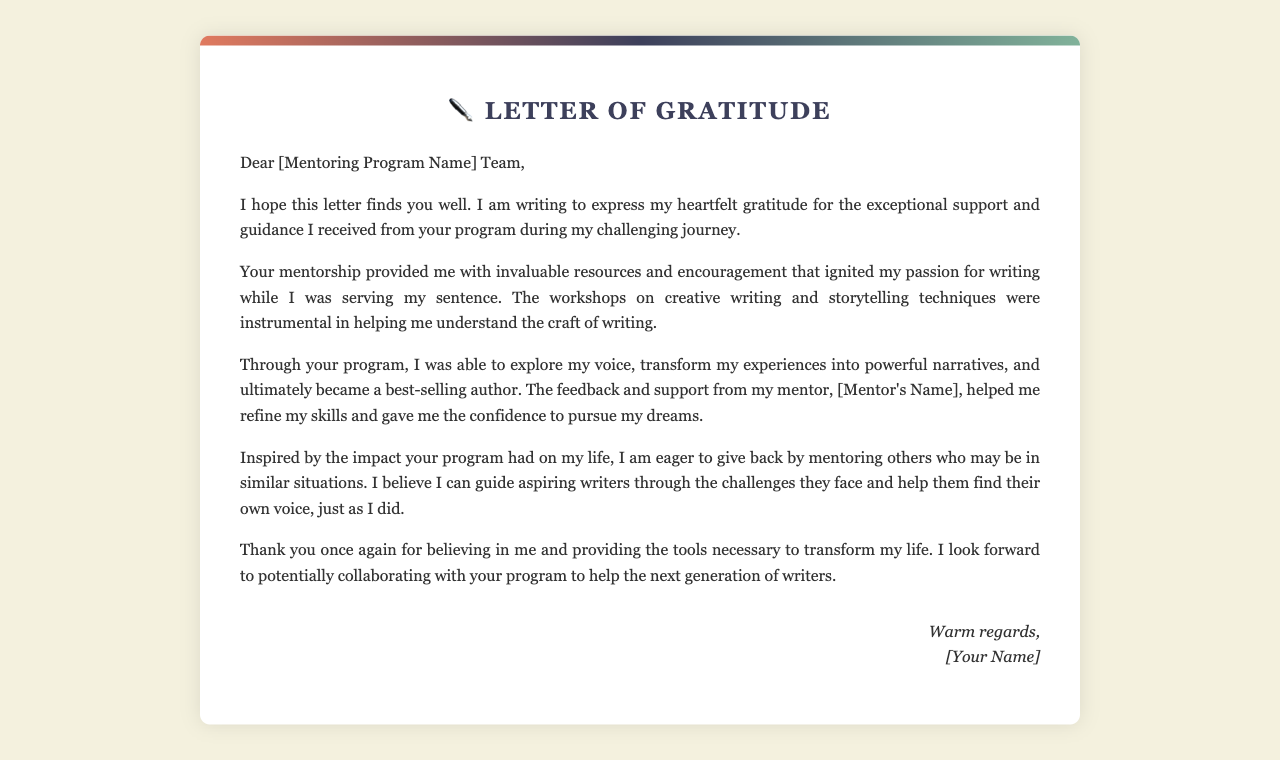what is the name of the letter? The letter is titled "Letter of Gratitude," which is mentioned at the top of the document.
Answer: Letter of Gratitude who is the recipient of the letter? The letter is addressed to the "[Mentoring Program Name] Team", indicating they are the intended recipients.
Answer: [Mentoring Program Name] Team what profession does the author identify as after receiving mentorship? The author mentions they ultimately became a "best-selling author" due to the program's influence.
Answer: best-selling author what type of workshops did the author participate in? The author participated in workshops on "creative writing and storytelling techniques," which helped them develop their skills.
Answer: creative writing and storytelling techniques what does the author wish to do in return for the program? The author expresses eagerness to "give back by mentoring others who may be in similar situations."
Answer: give back by mentoring others who provided feedback and support to the author? The mentor identified in the document is referred to as "[Mentor's Name]," highlighting their role in the author's development.
Answer: [Mentor's Name] what specific aspect of writing did the author transform? The author mentions transforming their "experiences into powerful narratives" through the guidance they received.
Answer: experiences into powerful narratives how does the author feel about the program's impact on their life? The author expresses "heartfelt gratitude" for the support and guidance provided by the program, indicating deep appreciation.
Answer: heartfelt gratitude what is the overall purpose of the letter? The primary purpose of the letter is to thank the mentoring program for their support and express a desire to collaborate in mentoring others.
Answer: to thank the mentoring program and offer to mentor others 